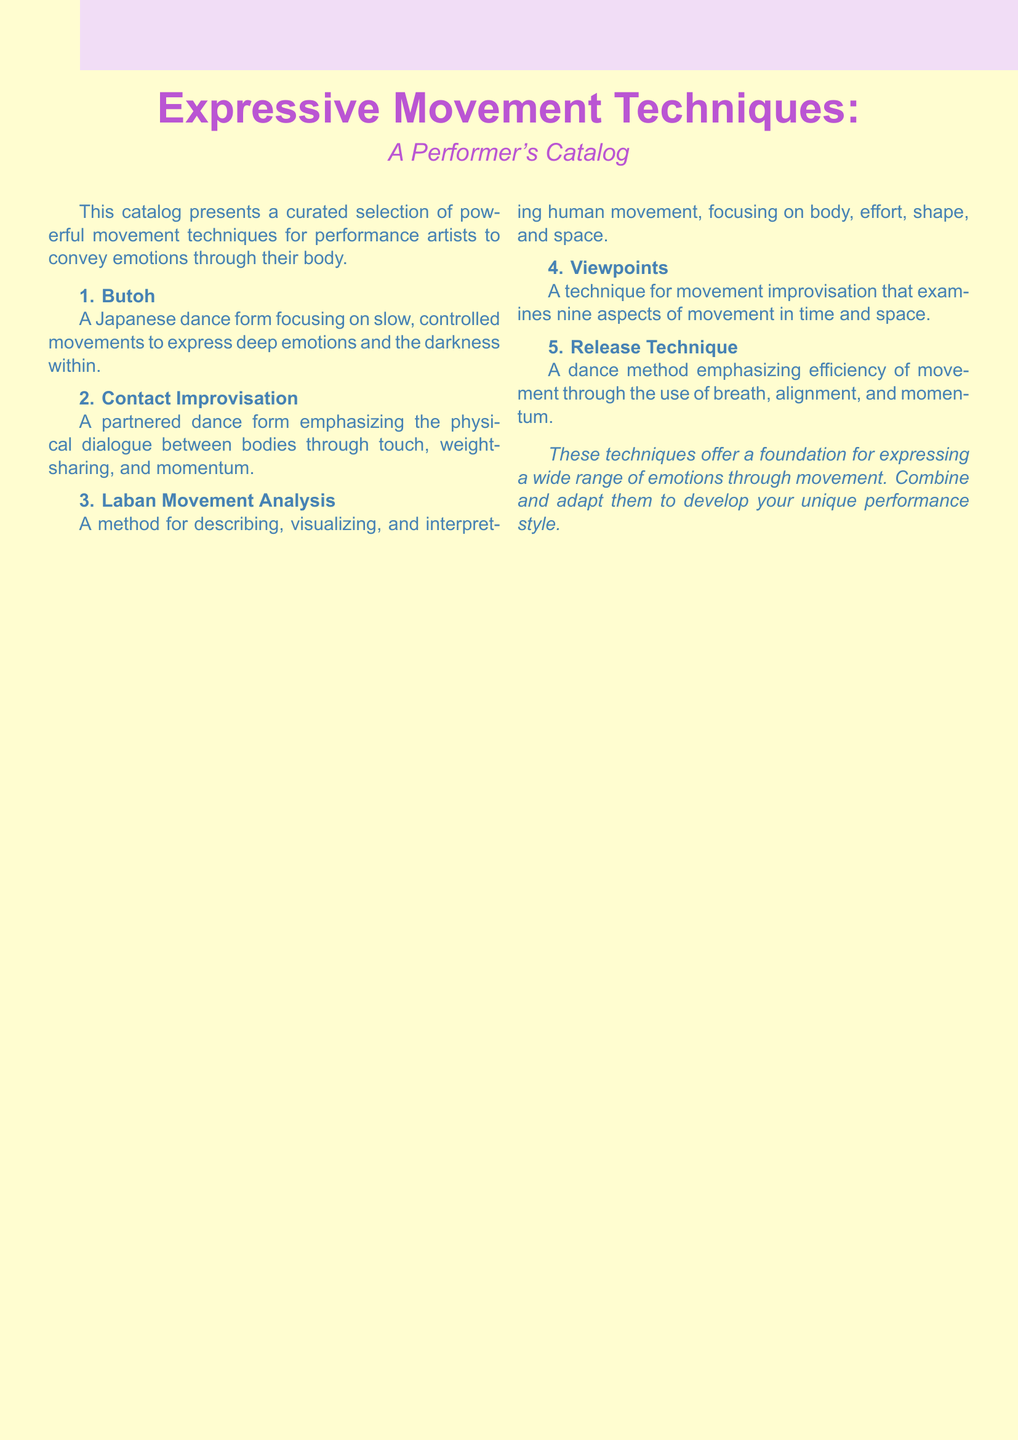What is the title of the catalog? The title of the catalog is presented prominently at the top of the document.
Answer: Expressive Movement Techniques How many movement techniques are listed in the catalog? The catalog lists a total of five distinct movement techniques.
Answer: 5 What is the first technique mentioned in the catalog? The first technique is listed at the beginning of the numbered section of the document.
Answer: Butoh Which technique emphasizes physical dialogue through touch? The question asks for the technique that focuses on interaction through physical contact.
Answer: Contact Improvisation What dance method focuses on efficiency of movement? The catalog describes a specific technique emphasizing movement efficiency.
Answer: Release Technique What are the nine aspects examined in the Viewpoints technique? The question highlights the technique that involves exploration of movement in time and space but does not list them, requiring reasoning.
Answer: Nine aspects of movement What is the color of the title in the document? The title is depicted in a specific color that is defined at the beginning of the document.
Answer: TitleColor (purple) Which movement technique is described as a Japanese dance form? The description provided indicates that one of the techniques has cultural origins from Japan.
Answer: Butoh 